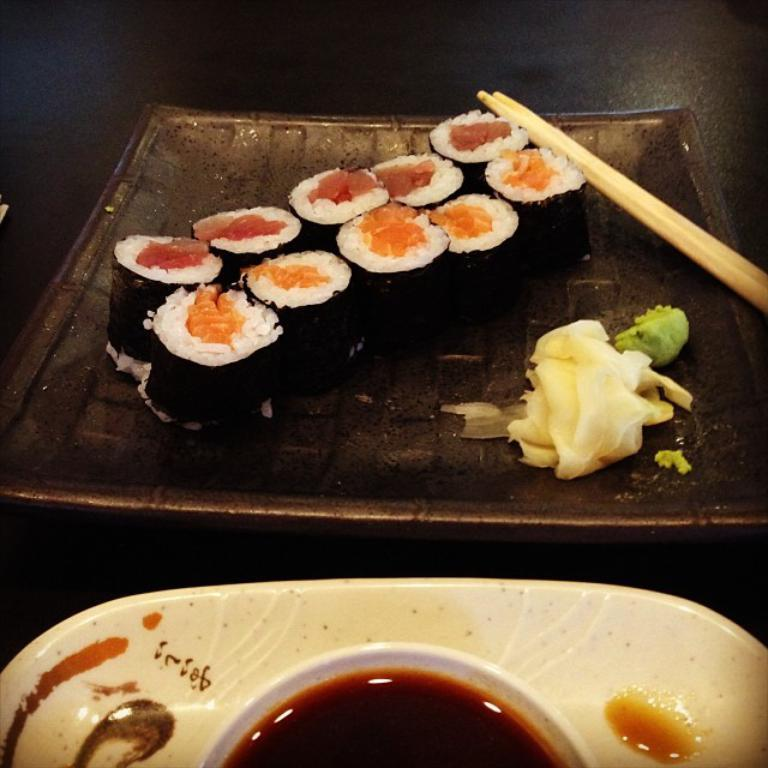What is on the plate that is visible in the image? There is food on the plate in the image. What type of utensil is present in the image? Chopsticks are present in the image. What color is the plate in the image? The plate in the image is white. What other dish is visible in the image besides the plate? There is a bowl in the image. What type of food is in the bowl? There is a liquid food in the bowl. Can you see a deer eating the food on the plate in the image? There is no deer present in the image. Is there a guide helping someone use the chopsticks in the image? There is no guide present in the image, and the use of chopsticks does not require assistance. 